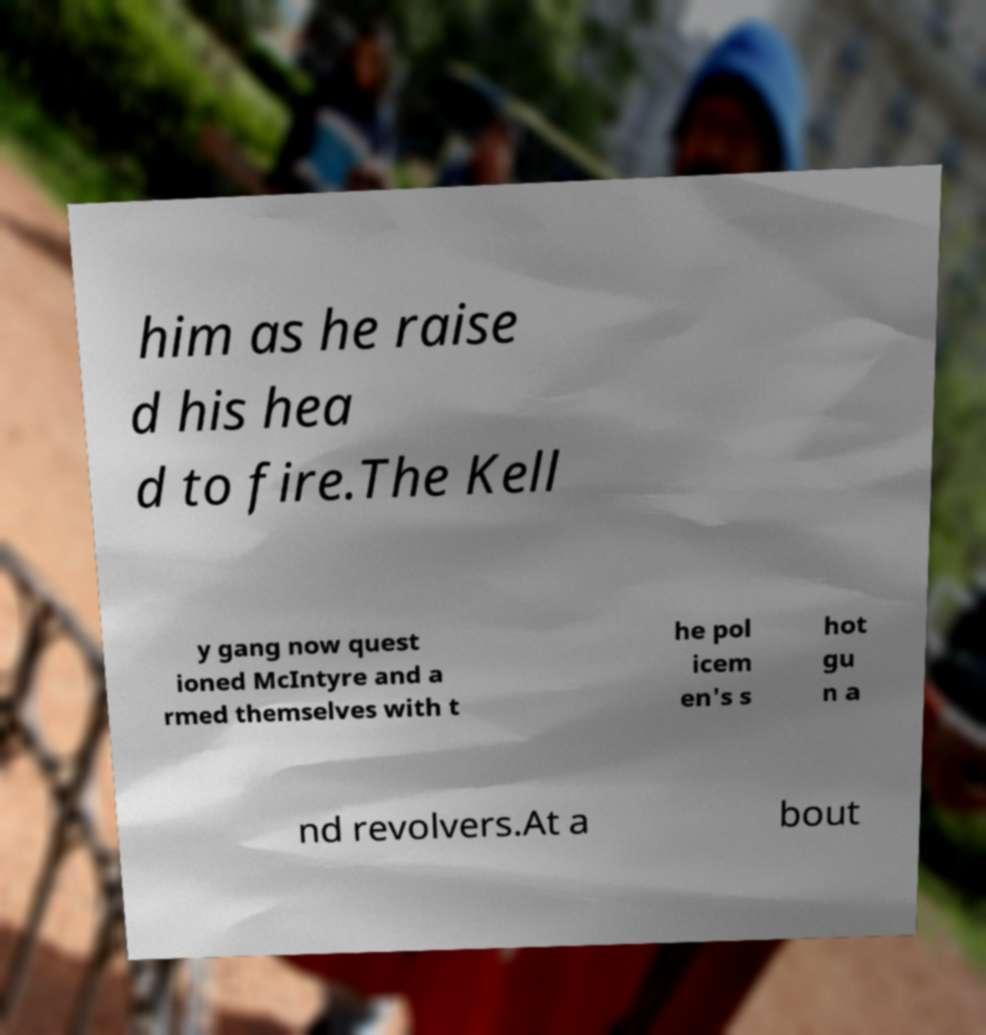For documentation purposes, I need the text within this image transcribed. Could you provide that? him as he raise d his hea d to fire.The Kell y gang now quest ioned McIntyre and a rmed themselves with t he pol icem en's s hot gu n a nd revolvers.At a bout 